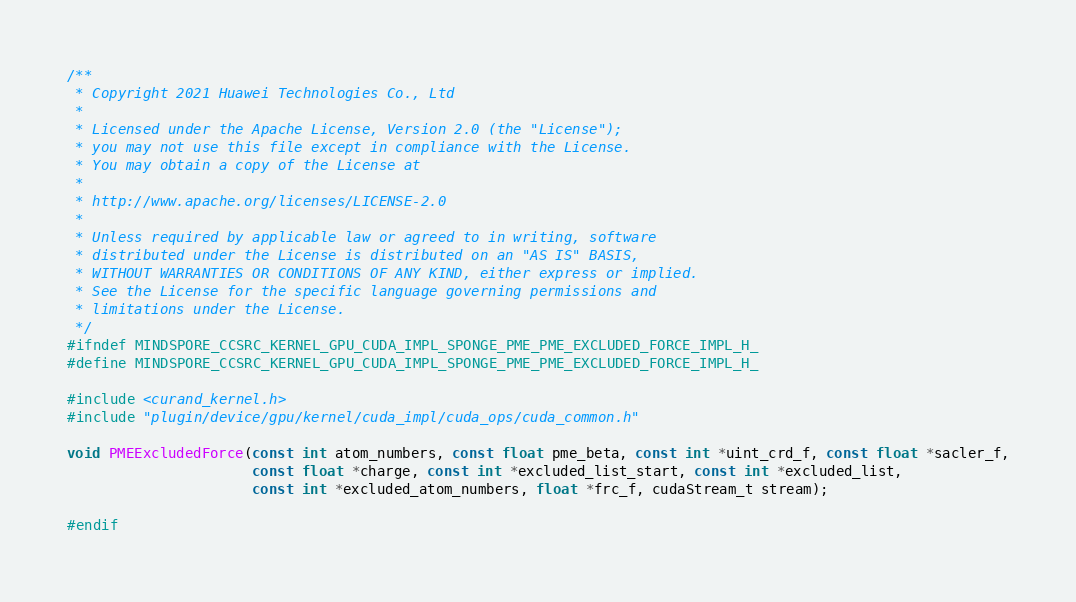Convert code to text. <code><loc_0><loc_0><loc_500><loc_500><_Cuda_>/**
 * Copyright 2021 Huawei Technologies Co., Ltd
 *
 * Licensed under the Apache License, Version 2.0 (the "License");
 * you may not use this file except in compliance with the License.
 * You may obtain a copy of the License at
 *
 * http://www.apache.org/licenses/LICENSE-2.0
 *
 * Unless required by applicable law or agreed to in writing, software
 * distributed under the License is distributed on an "AS IS" BASIS,
 * WITHOUT WARRANTIES OR CONDITIONS OF ANY KIND, either express or implied.
 * See the License for the specific language governing permissions and
 * limitations under the License.
 */
#ifndef MINDSPORE_CCSRC_KERNEL_GPU_CUDA_IMPL_SPONGE_PME_PME_EXCLUDED_FORCE_IMPL_H_
#define MINDSPORE_CCSRC_KERNEL_GPU_CUDA_IMPL_SPONGE_PME_PME_EXCLUDED_FORCE_IMPL_H_

#include <curand_kernel.h>
#include "plugin/device/gpu/kernel/cuda_impl/cuda_ops/cuda_common.h"

void PMEExcludedForce(const int atom_numbers, const float pme_beta, const int *uint_crd_f, const float *sacler_f,
                      const float *charge, const int *excluded_list_start, const int *excluded_list,
                      const int *excluded_atom_numbers, float *frc_f, cudaStream_t stream);

#endif
</code> 